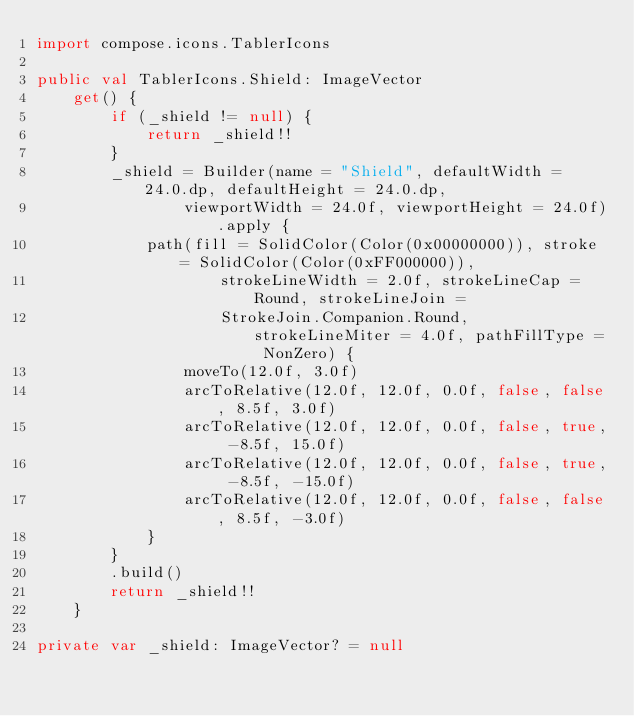<code> <loc_0><loc_0><loc_500><loc_500><_Kotlin_>import compose.icons.TablerIcons

public val TablerIcons.Shield: ImageVector
    get() {
        if (_shield != null) {
            return _shield!!
        }
        _shield = Builder(name = "Shield", defaultWidth = 24.0.dp, defaultHeight = 24.0.dp,
                viewportWidth = 24.0f, viewportHeight = 24.0f).apply {
            path(fill = SolidColor(Color(0x00000000)), stroke = SolidColor(Color(0xFF000000)),
                    strokeLineWidth = 2.0f, strokeLineCap = Round, strokeLineJoin =
                    StrokeJoin.Companion.Round, strokeLineMiter = 4.0f, pathFillType = NonZero) {
                moveTo(12.0f, 3.0f)
                arcToRelative(12.0f, 12.0f, 0.0f, false, false, 8.5f, 3.0f)
                arcToRelative(12.0f, 12.0f, 0.0f, false, true, -8.5f, 15.0f)
                arcToRelative(12.0f, 12.0f, 0.0f, false, true, -8.5f, -15.0f)
                arcToRelative(12.0f, 12.0f, 0.0f, false, false, 8.5f, -3.0f)
            }
        }
        .build()
        return _shield!!
    }

private var _shield: ImageVector? = null
</code> 